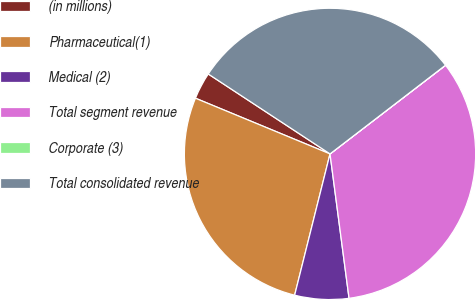Convert chart to OTSL. <chart><loc_0><loc_0><loc_500><loc_500><pie_chart><fcel>(in millions)<fcel>Pharmaceutical(1)<fcel>Medical (2)<fcel>Total segment revenue<fcel>Corporate (3)<fcel>Total consolidated revenue<nl><fcel>3.0%<fcel>27.34%<fcel>5.99%<fcel>33.33%<fcel>0.01%<fcel>30.33%<nl></chart> 